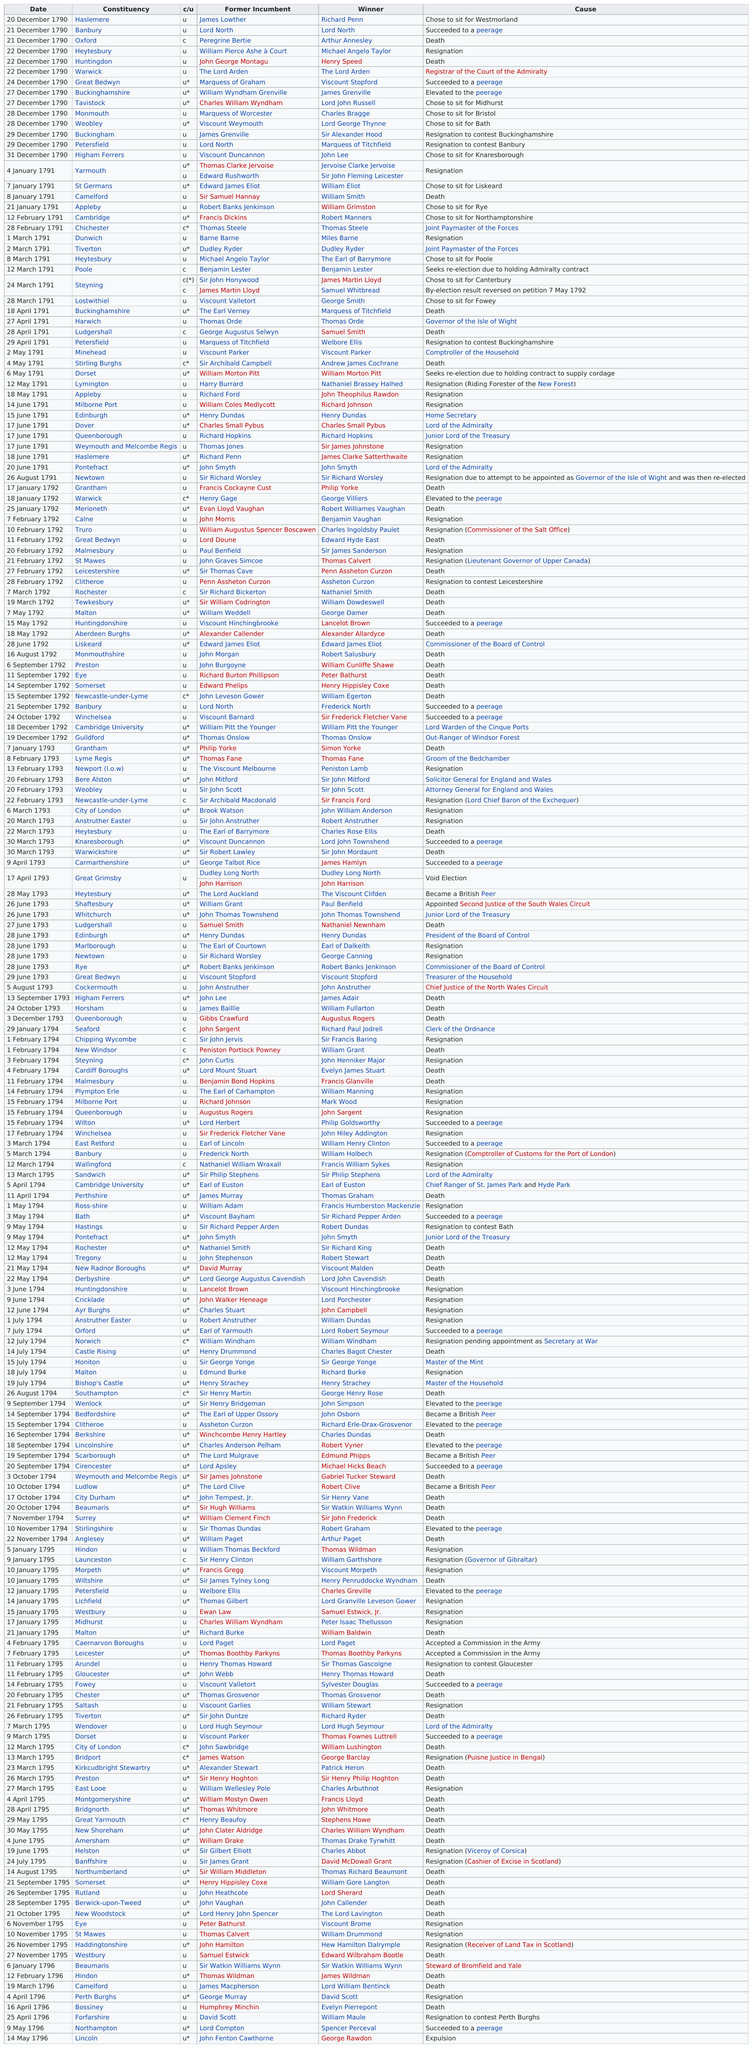List a handful of essential elements in this visual. What is the next date after the first date on the list, which is December 21, 1790? Arthur Annesley was the first winner of a contested poll. After Richard Ford resigned, William Coles Medlycott resigned as well. Charles William Wyndham, also known as the Marquess of Worcester, chose to sit for Bristol. John Lee won before Lord Hugh Seymour did. 